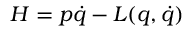Convert formula to latex. <formula><loc_0><loc_0><loc_500><loc_500>H = p \dot { q } - L ( q , \dot { q } )</formula> 